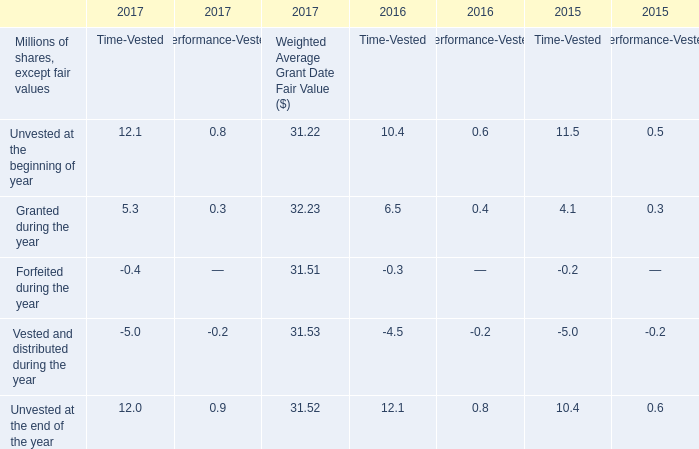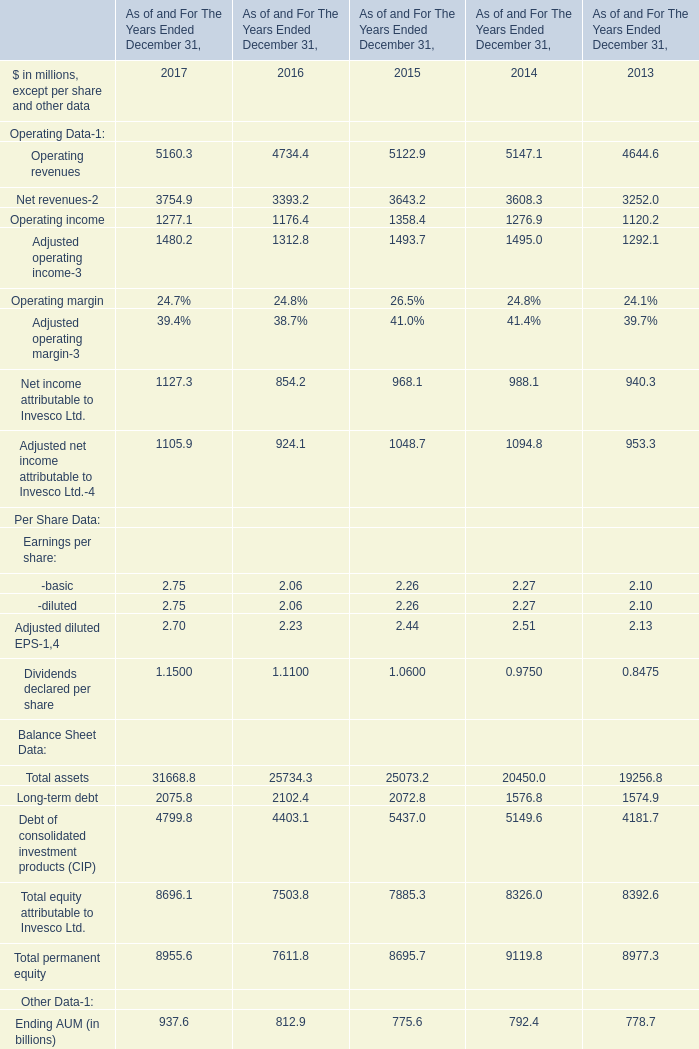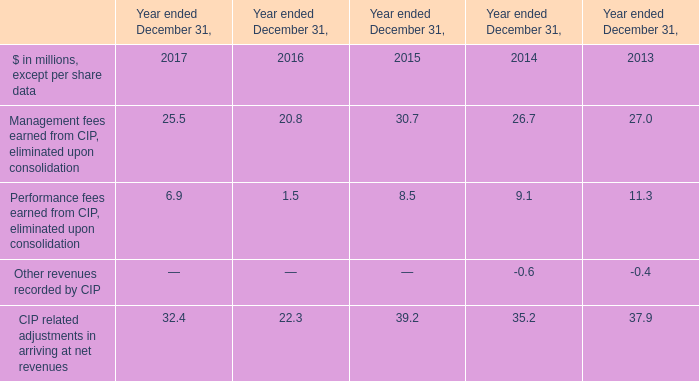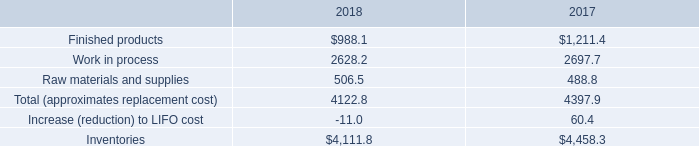In the year with largest amount of Operating revenues, what's the sum of Net revenues and Operating income ? (in million) 
Computations: (3754.9 + 1277.1)
Answer: 5032.0. 